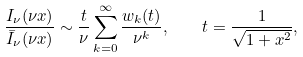Convert formula to latex. <formula><loc_0><loc_0><loc_500><loc_500>\frac { I _ { \nu } ( \nu x ) } { \bar { I } _ { \nu } ( \nu x ) } \sim \frac { t } { \nu } \sum _ { k = 0 } ^ { \infty } \frac { w _ { k } ( t ) } { \nu ^ { k } } , \quad t = \frac { 1 } { \sqrt { 1 + x ^ { 2 } } } ,</formula> 